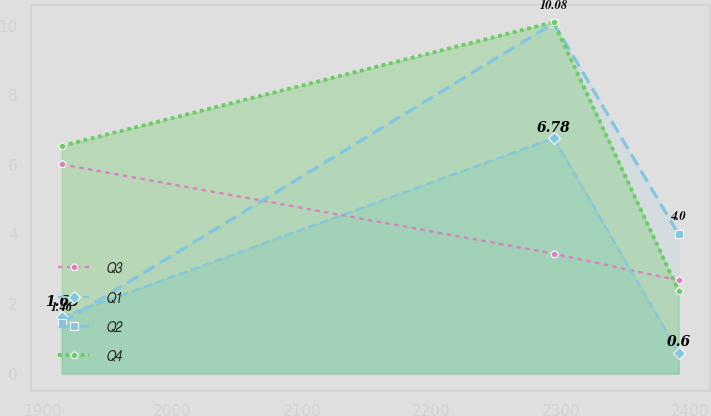Convert chart to OTSL. <chart><loc_0><loc_0><loc_500><loc_500><line_chart><ecel><fcel>Q3<fcel>Q1<fcel>Q2<fcel>Q4<nl><fcel>1914.56<fcel>6.02<fcel>1.63<fcel>1.46<fcel>6.55<nl><fcel>2294.6<fcel>3.45<fcel>6.78<fcel>10.08<fcel>10.11<nl><fcel>2391.1<fcel>2.68<fcel>0.6<fcel>4<fcel>2.37<nl></chart> 